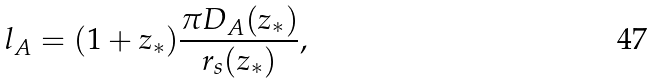Convert formula to latex. <formula><loc_0><loc_0><loc_500><loc_500>l _ { A } = ( 1 + z _ { * } ) \frac { \pi D _ { A } ( z _ { * } ) } { r _ { s } ( z _ { * } ) } ,</formula> 